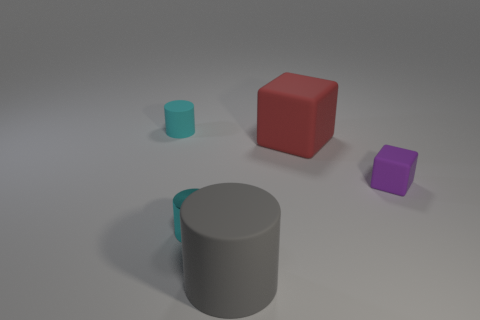There is a gray object that is the same shape as the tiny cyan metallic thing; what material is it?
Ensure brevity in your answer.  Rubber. Is there a cyan metal thing right of the small cyan thing right of the tiny thing that is behind the tiny cube?
Your answer should be very brief. No. There is a small object right of the big red object; does it have the same shape as the big rubber thing in front of the big red rubber object?
Offer a terse response. No. Is the number of cyan objects that are to the left of the big rubber cylinder greater than the number of tiny purple blocks?
Provide a short and direct response. Yes. What number of things are either yellow metal balls or small matte things?
Your answer should be very brief. 2. The tiny metal cylinder has what color?
Offer a terse response. Cyan. What number of other objects are there of the same color as the tiny metal cylinder?
Keep it short and to the point. 1. Are there any red cubes on the left side of the shiny object?
Keep it short and to the point. No. The matte cylinder that is in front of the object left of the tiny thing that is in front of the purple matte object is what color?
Give a very brief answer. Gray. What number of things are behind the large gray cylinder and in front of the cyan metallic cylinder?
Your answer should be very brief. 0. 